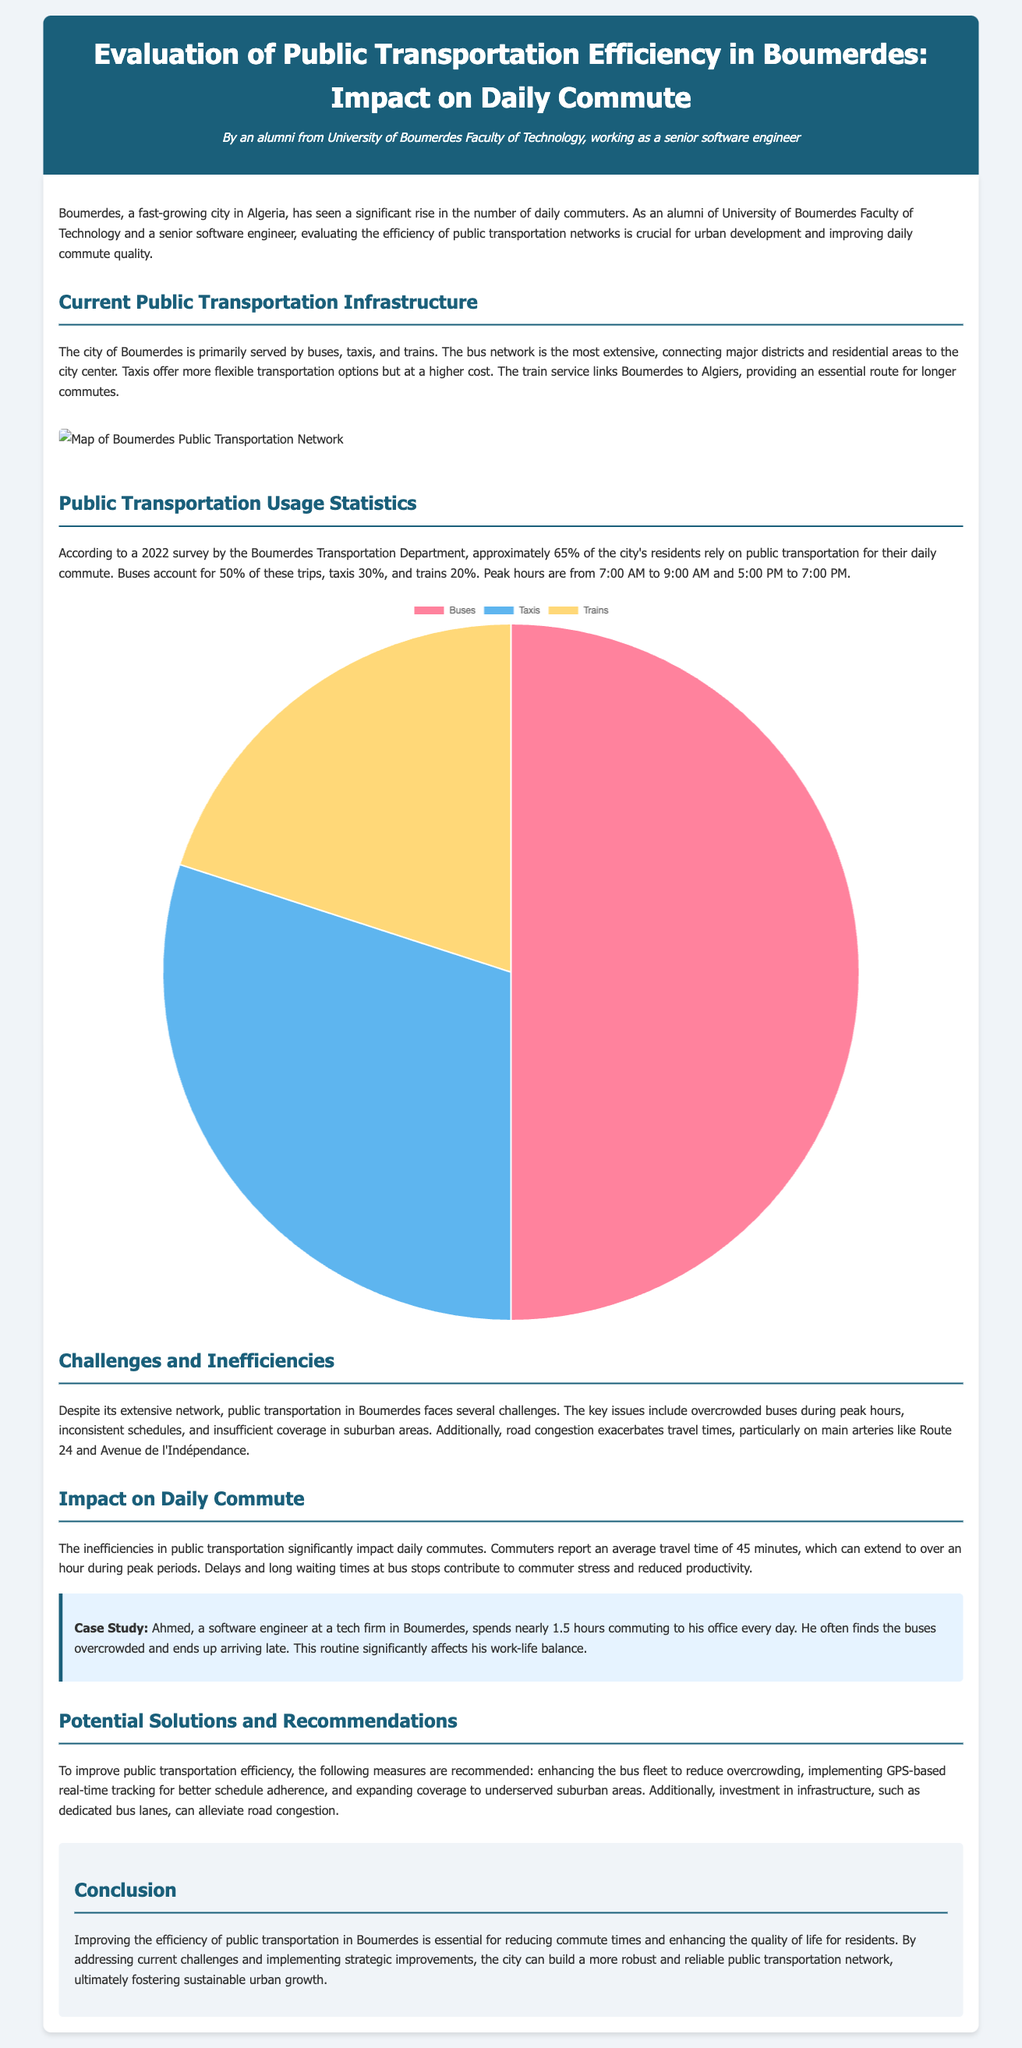What percentage of residents rely on public transportation? According to the 2022 survey, approximately 65% of the city's residents rely on public transportation for their daily commute.
Answer: 65% What is the peak hour for public transportation usage? The document states that peak hours are from 7:00 AM to 9:00 AM and 5:00 PM to 7:00 PM.
Answer: 7:00 AM to 9:00 AM and 5:00 PM to 7:00 PM What type of public transportation accounts for 50% of the trips? The document mentions that buses account for 50% of the trips made by residents.
Answer: Buses What challenges are faced by public transportation in Boumerdes? Key issues include overcrowded buses during peak hours, inconsistent schedules, and insufficient coverage in suburban areas.
Answer: Overcrowded buses, inconsistent schedules, insufficient coverage How long is the average travel time reported by commuters? The report indicates that commuters report an average travel time of 45 minutes.
Answer: 45 minutes What recommendation is given for improving public transportation? One of the recommendations includes enhancing the bus fleet to reduce overcrowding.
Answer: Enhancing the bus fleet Who is the case study based on? The case study in the document is based on Ahmed, a software engineer at a tech firm in Boumerdes.
Answer: Ahmed What mode of transportation links Boumerdes to Algiers? The train service is the mode of transportation that links Boumerdes to Algiers.
Answer: Train 